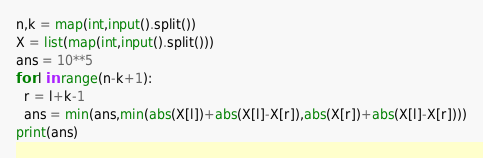Convert code to text. <code><loc_0><loc_0><loc_500><loc_500><_Python_>n,k = map(int,input().split())
X = list(map(int,input().split()))
ans = 10**5
for l in range(n-k+1):
  r = l+k-1 
  ans = min(ans,min(abs(X[l])+abs(X[l]-X[r]),abs(X[r])+abs(X[l]-X[r])))
print(ans)</code> 